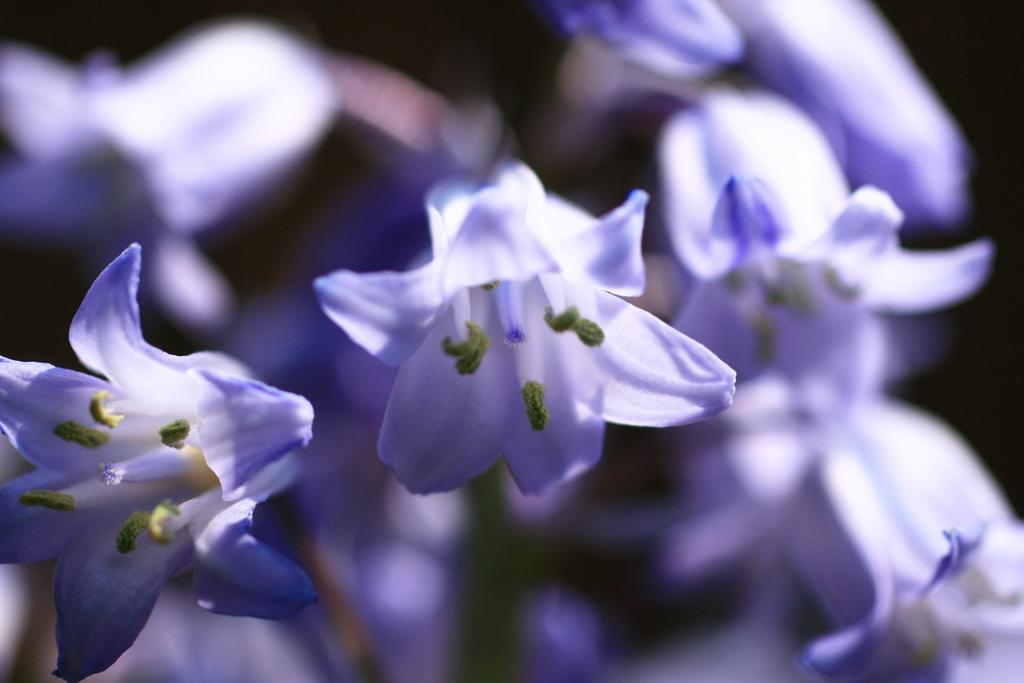What is in the foreground of the image? There are flowers in the foreground of the image. What is in the background of the image? There are flowers in the background of the image. How is the background of the image different from the foreground? The background of the image is blurred. What type of pies are being served in the aftermath of the event in the image? There is no event or pies present in the image; it features flowers in the foreground and background with a blurred background. 